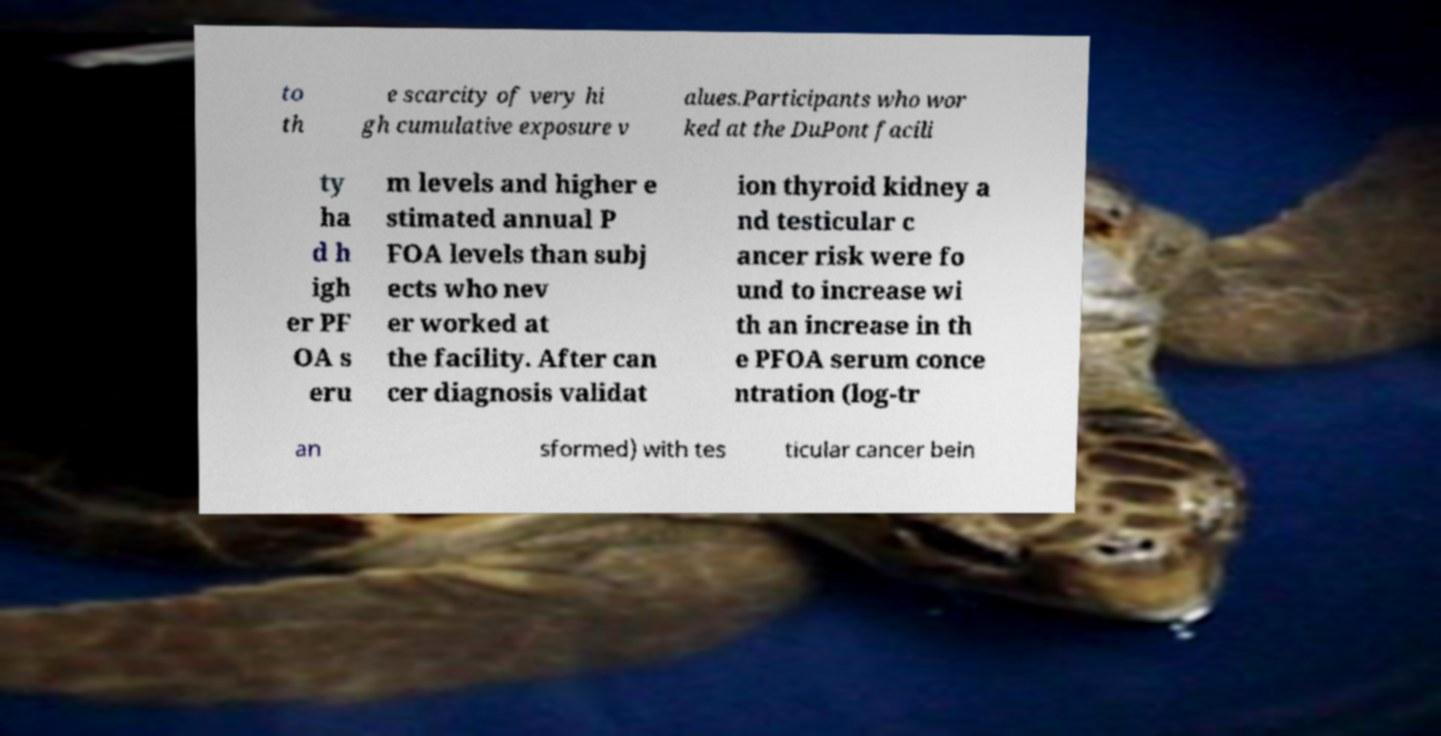Could you extract and type out the text from this image? to th e scarcity of very hi gh cumulative exposure v alues.Participants who wor ked at the DuPont facili ty ha d h igh er PF OA s eru m levels and higher e stimated annual P FOA levels than subj ects who nev er worked at the facility. After can cer diagnosis validat ion thyroid kidney a nd testicular c ancer risk were fo und to increase wi th an increase in th e PFOA serum conce ntration (log-tr an sformed) with tes ticular cancer bein 